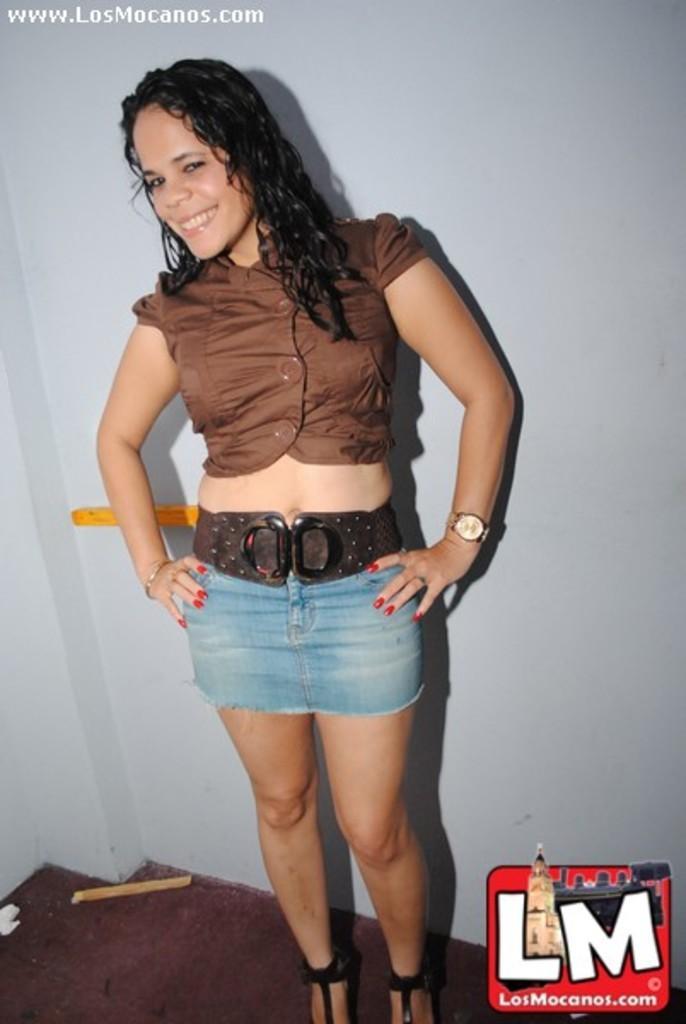In one or two sentences, can you explain what this image depicts? In this image I can see a woman wearing black and brown colored dress is stunning. I can see the white colored wall in the background. 